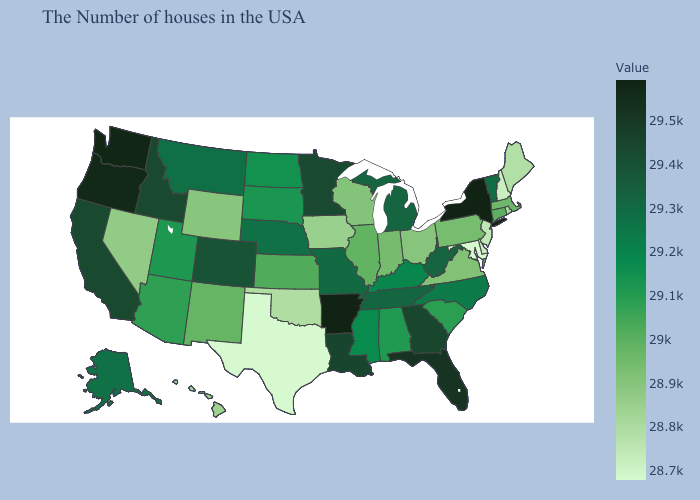Among the states that border Pennsylvania , which have the lowest value?
Give a very brief answer. Maryland. Which states have the highest value in the USA?
Quick response, please. New York. Which states have the lowest value in the MidWest?
Concise answer only. Iowa. Which states have the lowest value in the USA?
Quick response, please. Maryland. Does Rhode Island have the highest value in the Northeast?
Answer briefly. No. Among the states that border Michigan , which have the lowest value?
Answer briefly. Ohio. Among the states that border Arkansas , does Missouri have the lowest value?
Quick response, please. No. Does Maryland have the lowest value in the USA?
Keep it brief. Yes. 